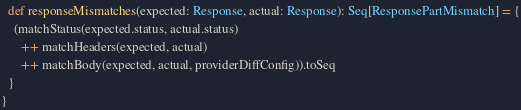Convert code to text. <code><loc_0><loc_0><loc_500><loc_500><_Scala_>  def responseMismatches(expected: Response, actual: Response): Seq[ResponsePartMismatch] = {
    (matchStatus(expected.status, actual.status) 
      ++ matchHeaders(expected, actual)
      ++ matchBody(expected, actual, providerDiffConfig)).toSeq
  }
}
</code> 